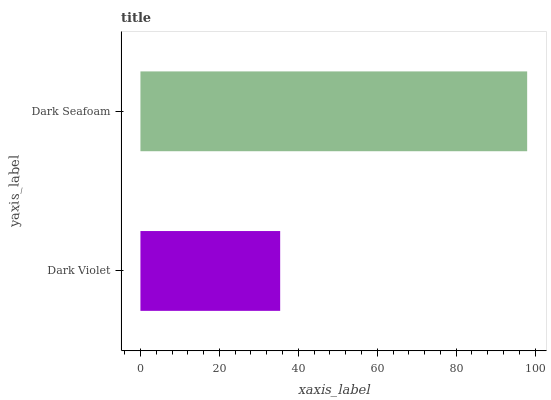Is Dark Violet the minimum?
Answer yes or no. Yes. Is Dark Seafoam the maximum?
Answer yes or no. Yes. Is Dark Seafoam the minimum?
Answer yes or no. No. Is Dark Seafoam greater than Dark Violet?
Answer yes or no. Yes. Is Dark Violet less than Dark Seafoam?
Answer yes or no. Yes. Is Dark Violet greater than Dark Seafoam?
Answer yes or no. No. Is Dark Seafoam less than Dark Violet?
Answer yes or no. No. Is Dark Seafoam the high median?
Answer yes or no. Yes. Is Dark Violet the low median?
Answer yes or no. Yes. Is Dark Violet the high median?
Answer yes or no. No. Is Dark Seafoam the low median?
Answer yes or no. No. 